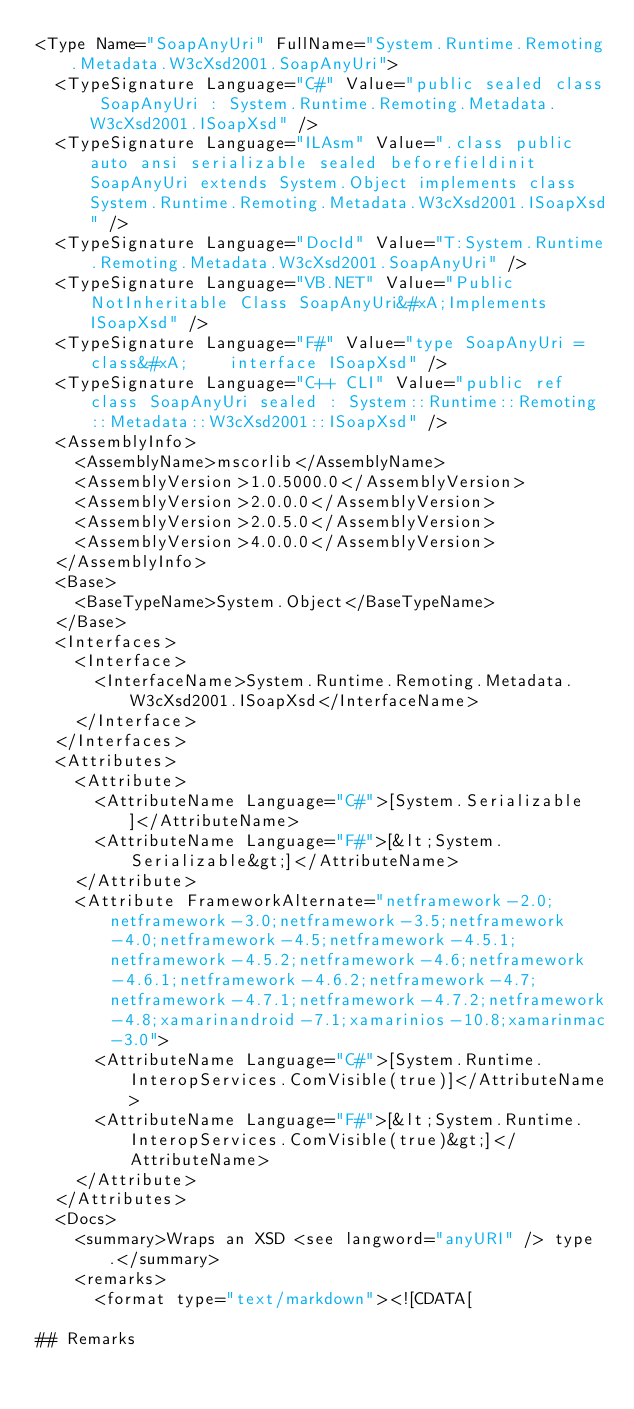Convert code to text. <code><loc_0><loc_0><loc_500><loc_500><_XML_><Type Name="SoapAnyUri" FullName="System.Runtime.Remoting.Metadata.W3cXsd2001.SoapAnyUri">
  <TypeSignature Language="C#" Value="public sealed class SoapAnyUri : System.Runtime.Remoting.Metadata.W3cXsd2001.ISoapXsd" />
  <TypeSignature Language="ILAsm" Value=".class public auto ansi serializable sealed beforefieldinit SoapAnyUri extends System.Object implements class System.Runtime.Remoting.Metadata.W3cXsd2001.ISoapXsd" />
  <TypeSignature Language="DocId" Value="T:System.Runtime.Remoting.Metadata.W3cXsd2001.SoapAnyUri" />
  <TypeSignature Language="VB.NET" Value="Public NotInheritable Class SoapAnyUri&#xA;Implements ISoapXsd" />
  <TypeSignature Language="F#" Value="type SoapAnyUri = class&#xA;    interface ISoapXsd" />
  <TypeSignature Language="C++ CLI" Value="public ref class SoapAnyUri sealed : System::Runtime::Remoting::Metadata::W3cXsd2001::ISoapXsd" />
  <AssemblyInfo>
    <AssemblyName>mscorlib</AssemblyName>
    <AssemblyVersion>1.0.5000.0</AssemblyVersion>
    <AssemblyVersion>2.0.0.0</AssemblyVersion>
    <AssemblyVersion>2.0.5.0</AssemblyVersion>
    <AssemblyVersion>4.0.0.0</AssemblyVersion>
  </AssemblyInfo>
  <Base>
    <BaseTypeName>System.Object</BaseTypeName>
  </Base>
  <Interfaces>
    <Interface>
      <InterfaceName>System.Runtime.Remoting.Metadata.W3cXsd2001.ISoapXsd</InterfaceName>
    </Interface>
  </Interfaces>
  <Attributes>
    <Attribute>
      <AttributeName Language="C#">[System.Serializable]</AttributeName>
      <AttributeName Language="F#">[&lt;System.Serializable&gt;]</AttributeName>
    </Attribute>
    <Attribute FrameworkAlternate="netframework-2.0;netframework-3.0;netframework-3.5;netframework-4.0;netframework-4.5;netframework-4.5.1;netframework-4.5.2;netframework-4.6;netframework-4.6.1;netframework-4.6.2;netframework-4.7;netframework-4.7.1;netframework-4.7.2;netframework-4.8;xamarinandroid-7.1;xamarinios-10.8;xamarinmac-3.0">
      <AttributeName Language="C#">[System.Runtime.InteropServices.ComVisible(true)]</AttributeName>
      <AttributeName Language="F#">[&lt;System.Runtime.InteropServices.ComVisible(true)&gt;]</AttributeName>
    </Attribute>
  </Attributes>
  <Docs>
    <summary>Wraps an XSD <see langword="anyURI" /> type.</summary>
    <remarks>
      <format type="text/markdown"><![CDATA[  
  
## Remarks  
</code> 